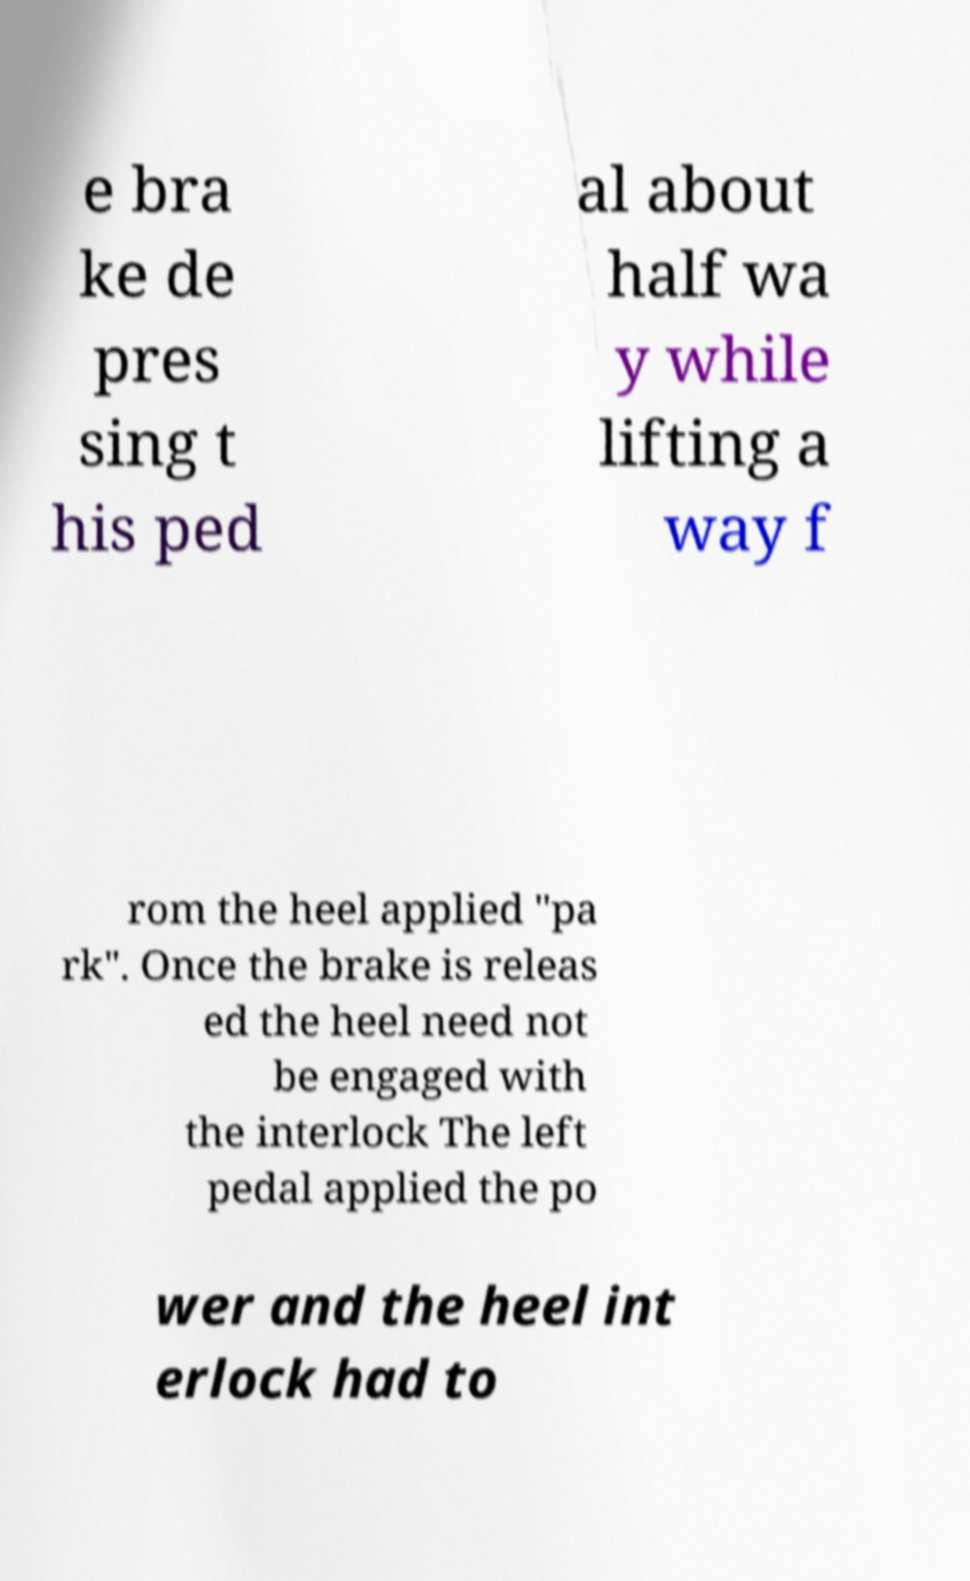For documentation purposes, I need the text within this image transcribed. Could you provide that? e bra ke de pres sing t his ped al about half wa y while lifting a way f rom the heel applied "pa rk". Once the brake is releas ed the heel need not be engaged with the interlock The left pedal applied the po wer and the heel int erlock had to 